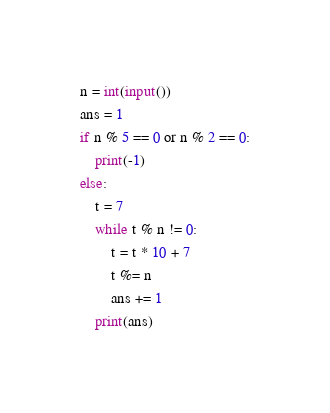Convert code to text. <code><loc_0><loc_0><loc_500><loc_500><_Python_>n = int(input())
ans = 1
if n % 5 == 0 or n % 2 == 0:
    print(-1)
else:
    t = 7
    while t % n != 0:
        t = t * 10 + 7
        t %= n
        ans += 1
    print(ans)
</code> 